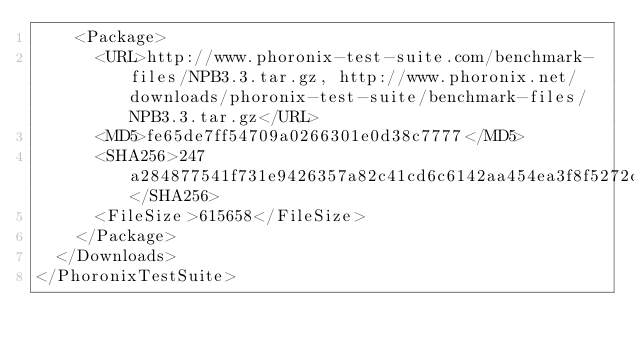Convert code to text. <code><loc_0><loc_0><loc_500><loc_500><_XML_>    <Package>
      <URL>http://www.phoronix-test-suite.com/benchmark-files/NPB3.3.tar.gz, http://www.phoronix.net/downloads/phoronix-test-suite/benchmark-files/NPB3.3.tar.gz</URL>
      <MD5>fe65de7ff54709a0266301e0d38c7777</MD5>
      <SHA256>247a284877541f731e9426357a82c41cd6c6142aa454ea3f8f5272dbcb4b93da</SHA256>
      <FileSize>615658</FileSize>
    </Package>
  </Downloads>
</PhoronixTestSuite>
</code> 